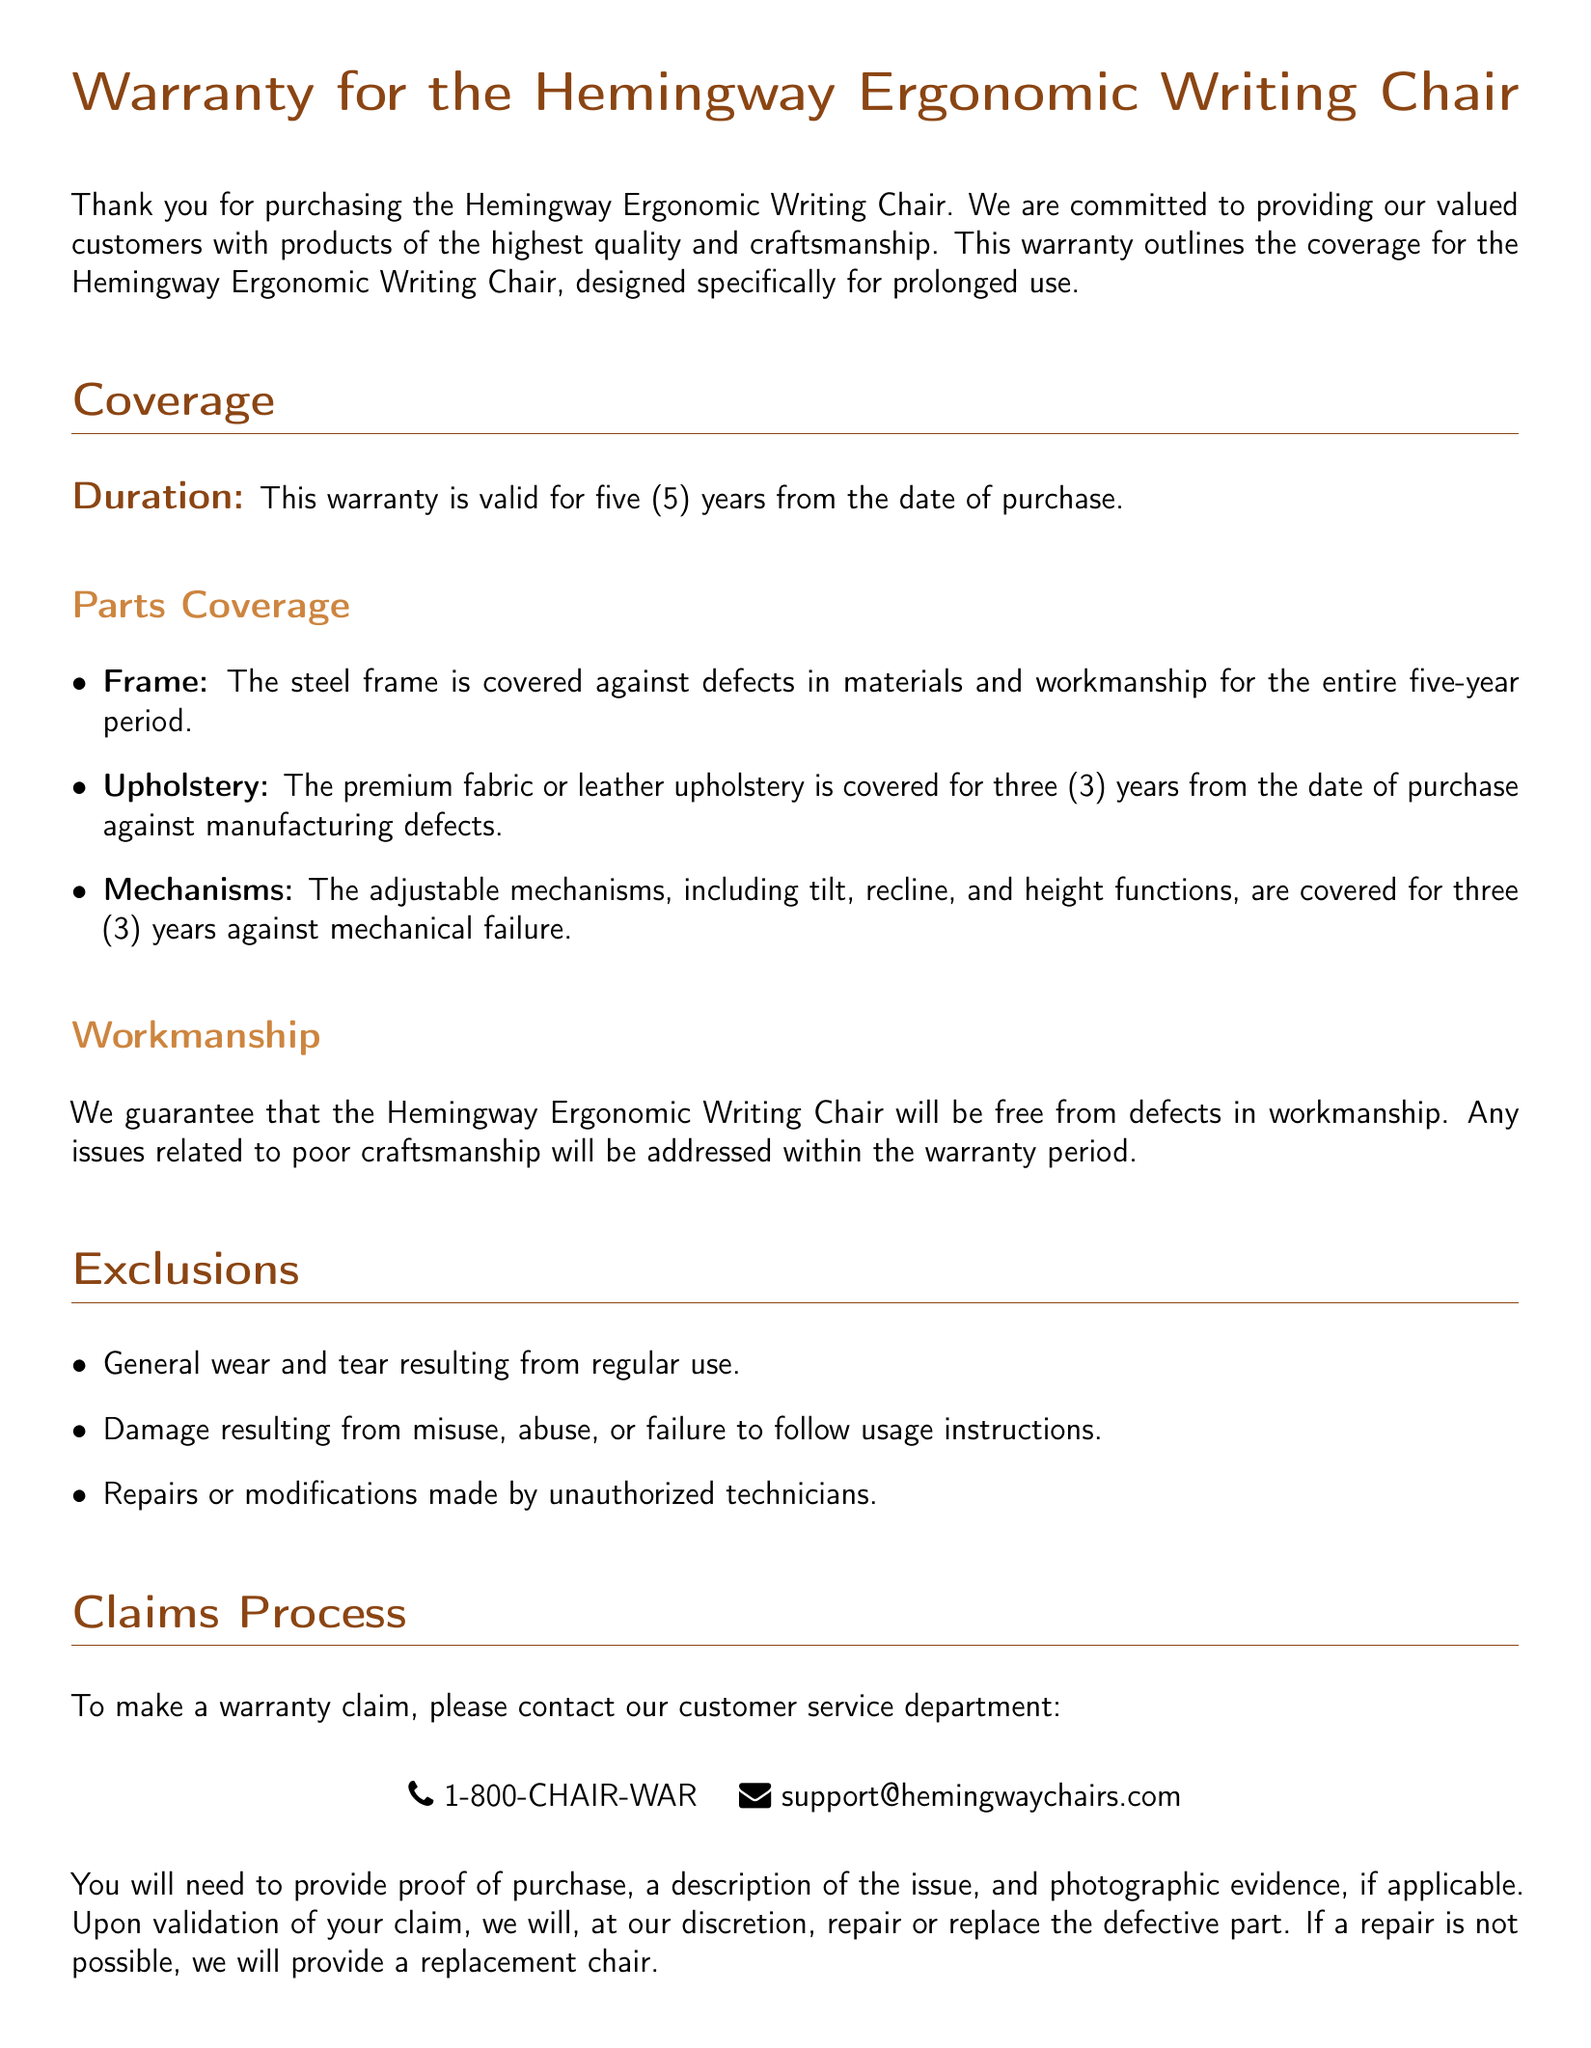What is the duration of the warranty? The warranty is valid for five (5) years from the date of purchase.
Answer: five (5) years What components are covered under parts coverage? The document specifies that the frame, upholstery, and mechanisms are covered.
Answer: frame, upholstery, mechanisms How long is the upholstery covered? The upholstery is covered for three (3) years from the date of purchase against manufacturing defects.
Answer: three (3) years What should be provided to make a warranty claim? The claim requires proof of purchase, a description of the issue, and photographic evidence, if applicable.
Answer: proof of purchase, description of the issue, photographic evidence Are general wear and tear covered under the warranty? The document explicitly states that general wear and tear resulting from regular use is excluded from coverage.
Answer: No Is the warranty transferable? The document mentions that the warranty is non-transferable and applies only to the original purchaser.
Answer: No What is the contact number for warranty claims? The contact number provided for warranty claims in the document is 1-800-CHAIR-WAR.
Answer: 1-800-CHAIR-WAR What is guaranteed regarding the workmanship of the chair? The warranty guarantees that the chair will be free from defects in workmanship.
Answer: free from defects in workmanship 